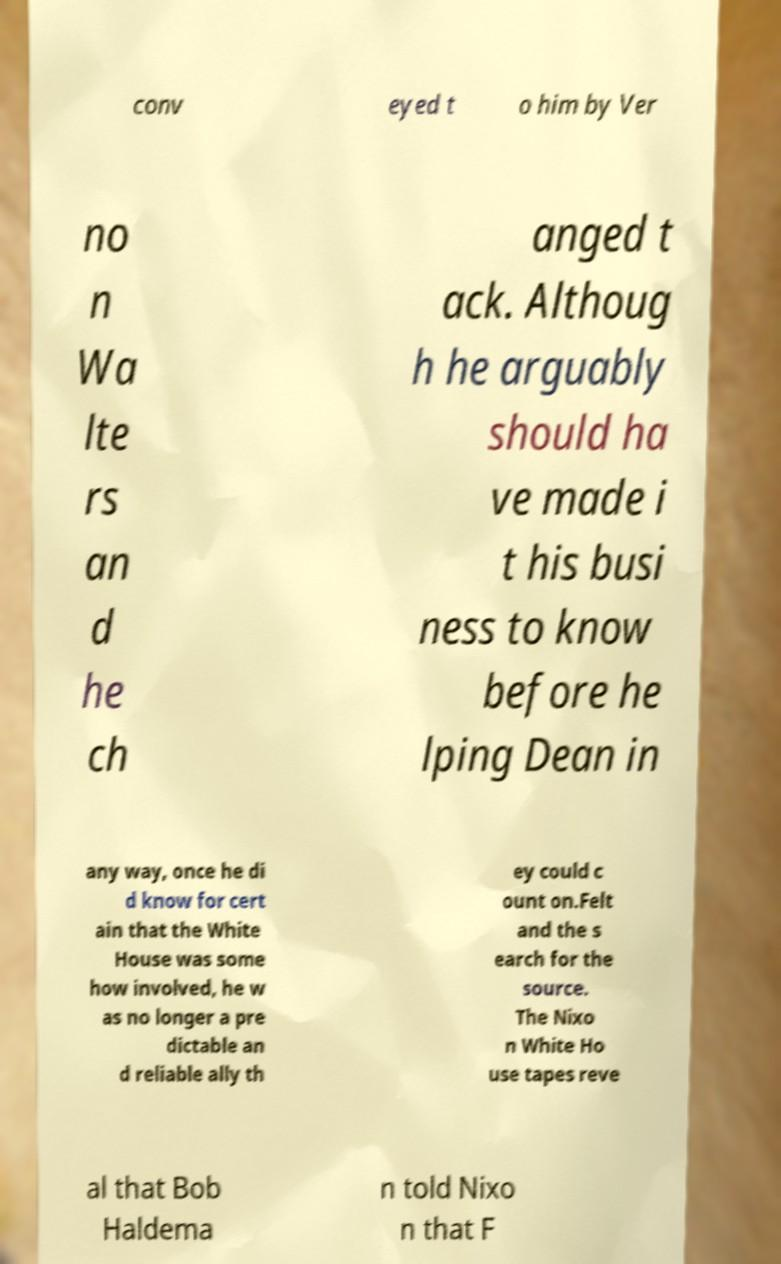Please read and relay the text visible in this image. What does it say? conv eyed t o him by Ver no n Wa lte rs an d he ch anged t ack. Althoug h he arguably should ha ve made i t his busi ness to know before he lping Dean in any way, once he di d know for cert ain that the White House was some how involved, he w as no longer a pre dictable an d reliable ally th ey could c ount on.Felt and the s earch for the source. The Nixo n White Ho use tapes reve al that Bob Haldema n told Nixo n that F 